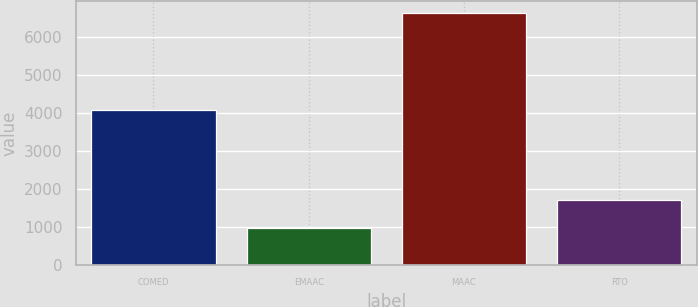Convert chart to OTSL. <chart><loc_0><loc_0><loc_500><loc_500><bar_chart><fcel>COMED<fcel>EMAAC<fcel>MAAC<fcel>RTO<nl><fcel>4088<fcel>981<fcel>6618<fcel>1701<nl></chart> 